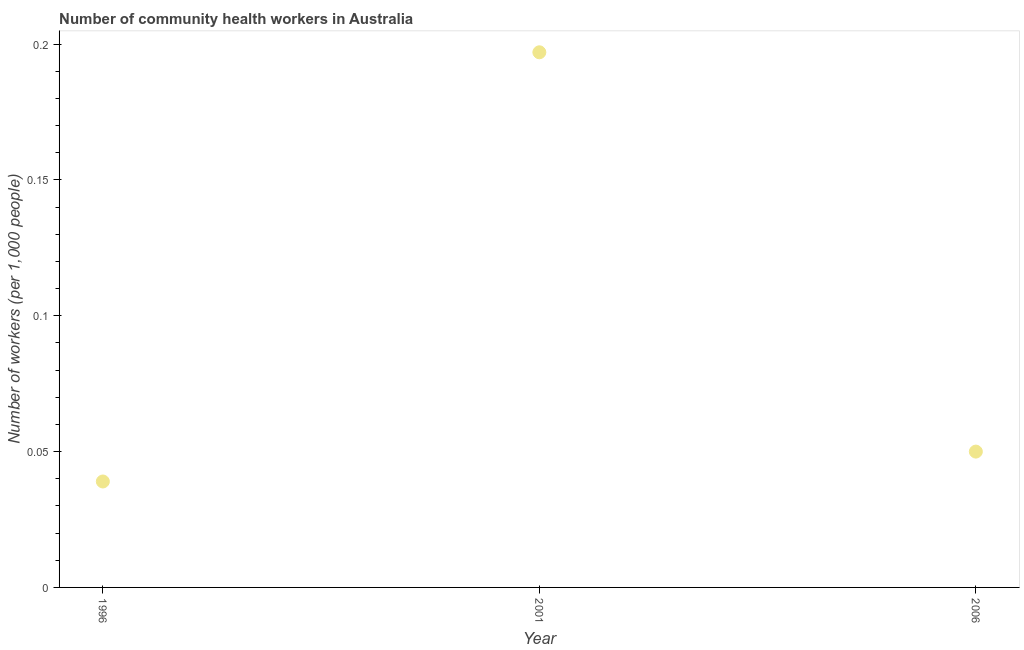What is the number of community health workers in 1996?
Your response must be concise. 0.04. Across all years, what is the maximum number of community health workers?
Offer a very short reply. 0.2. Across all years, what is the minimum number of community health workers?
Ensure brevity in your answer.  0.04. In which year was the number of community health workers maximum?
Ensure brevity in your answer.  2001. What is the sum of the number of community health workers?
Your response must be concise. 0.29. What is the difference between the number of community health workers in 2001 and 2006?
Offer a very short reply. 0.15. What is the average number of community health workers per year?
Provide a succinct answer. 0.1. What is the median number of community health workers?
Offer a very short reply. 0.05. What is the ratio of the number of community health workers in 1996 to that in 2001?
Offer a very short reply. 0.2. Is the difference between the number of community health workers in 2001 and 2006 greater than the difference between any two years?
Provide a succinct answer. No. What is the difference between the highest and the second highest number of community health workers?
Offer a very short reply. 0.15. Is the sum of the number of community health workers in 1996 and 2001 greater than the maximum number of community health workers across all years?
Offer a very short reply. Yes. What is the difference between the highest and the lowest number of community health workers?
Provide a succinct answer. 0.16. Does the number of community health workers monotonically increase over the years?
Offer a terse response. No. What is the difference between two consecutive major ticks on the Y-axis?
Ensure brevity in your answer.  0.05. Does the graph contain any zero values?
Give a very brief answer. No. Does the graph contain grids?
Your answer should be compact. No. What is the title of the graph?
Offer a terse response. Number of community health workers in Australia. What is the label or title of the Y-axis?
Make the answer very short. Number of workers (per 1,0 people). What is the Number of workers (per 1,000 people) in 1996?
Provide a short and direct response. 0.04. What is the Number of workers (per 1,000 people) in 2001?
Provide a short and direct response. 0.2. What is the difference between the Number of workers (per 1,000 people) in 1996 and 2001?
Offer a terse response. -0.16. What is the difference between the Number of workers (per 1,000 people) in 1996 and 2006?
Offer a terse response. -0.01. What is the difference between the Number of workers (per 1,000 people) in 2001 and 2006?
Provide a succinct answer. 0.15. What is the ratio of the Number of workers (per 1,000 people) in 1996 to that in 2001?
Provide a short and direct response. 0.2. What is the ratio of the Number of workers (per 1,000 people) in 1996 to that in 2006?
Keep it short and to the point. 0.78. What is the ratio of the Number of workers (per 1,000 people) in 2001 to that in 2006?
Provide a short and direct response. 3.94. 